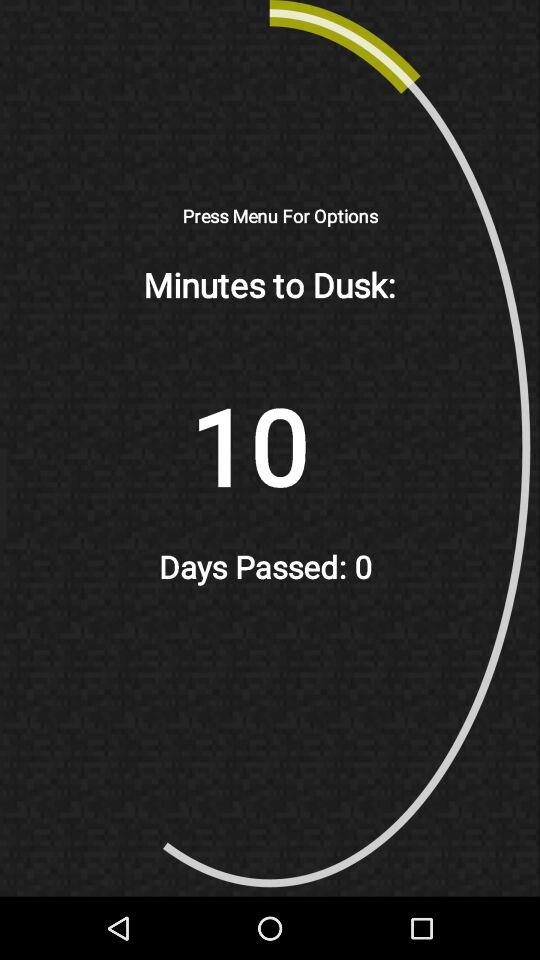How many minutes until dusk?
Answer the question using a single word or phrase. 10 